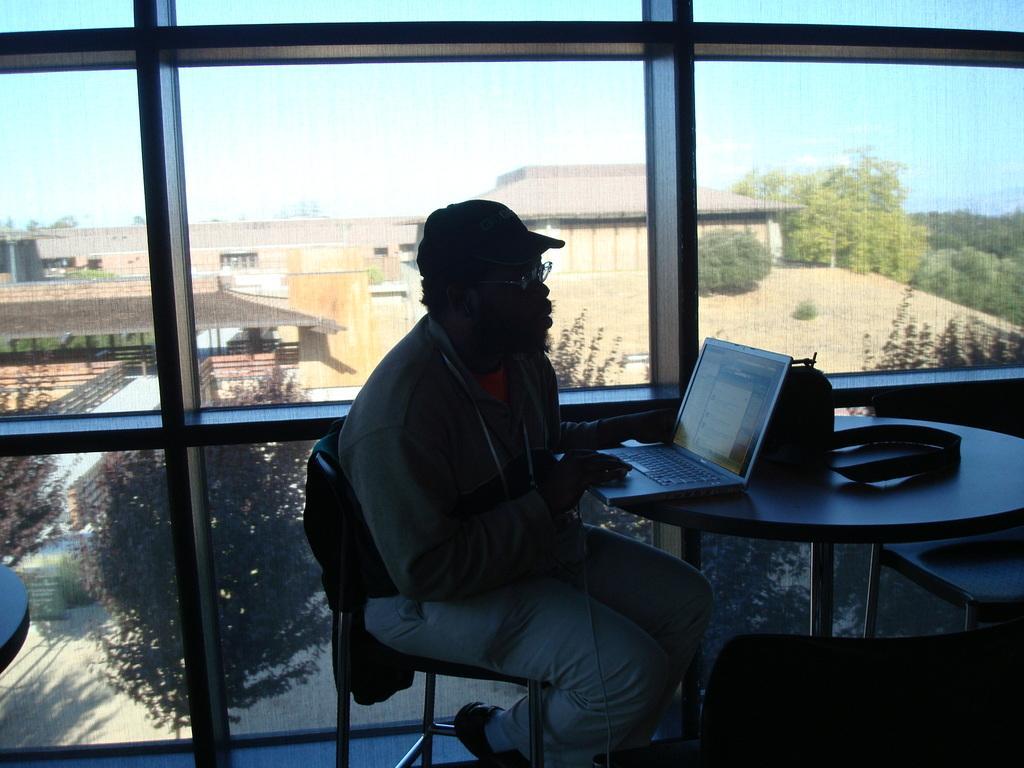Describe this image in one or two sentences. Person sitting on the chair using laptop,here there is table and the chair,this is glass and here in the background tree,this is building. 